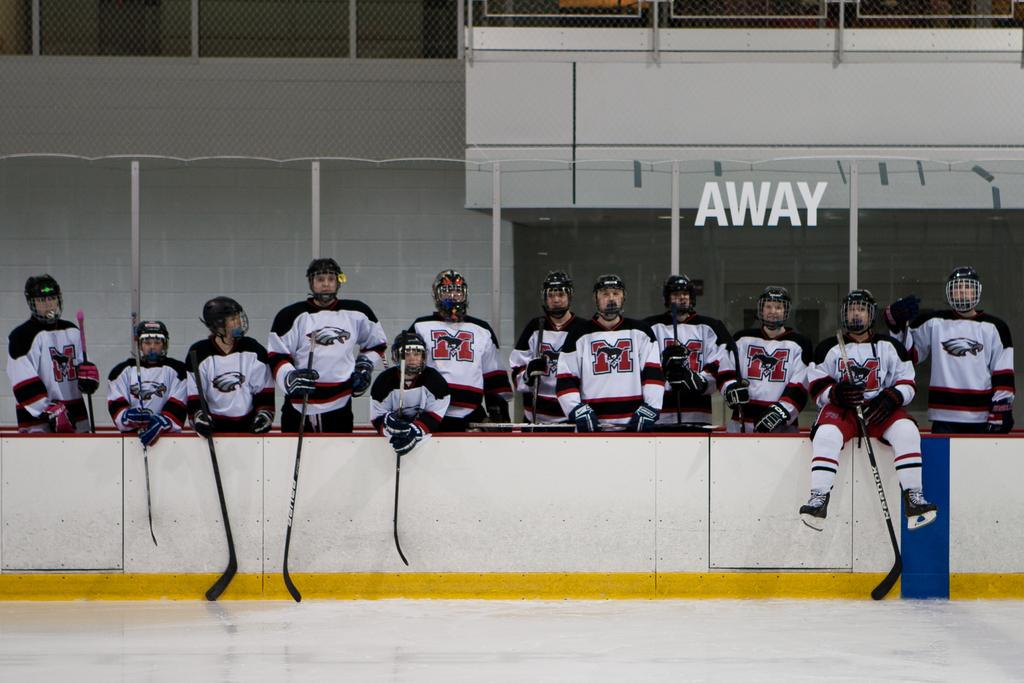<image>
Relay a brief, clear account of the picture shown. Twelve hockey players are standing behind a barrier wearing matching uniforms with an M in the center. 